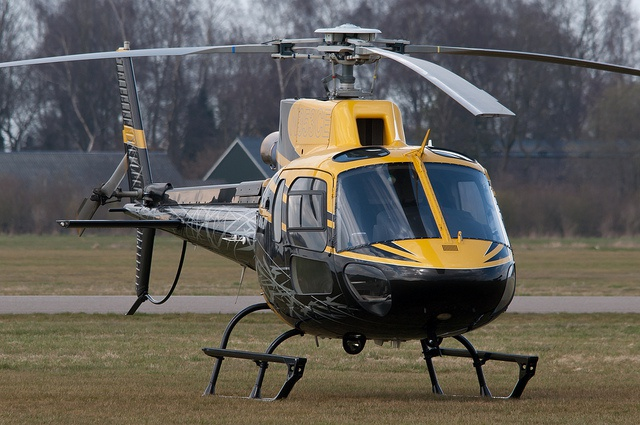Describe the objects in this image and their specific colors. I can see various objects in this image with different colors. 